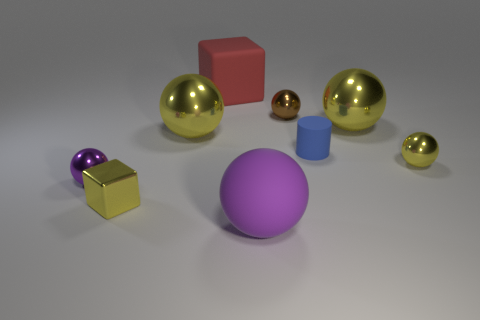There is a matte sphere; is it the same color as the tiny metallic thing that is on the left side of the tiny metal cube?
Offer a terse response. Yes. There is a object that is the same color as the big rubber ball; what shape is it?
Your response must be concise. Sphere. There is a brown metal ball; what number of small yellow shiny things are on the right side of it?
Offer a very short reply. 1. There is a large metallic ball on the left side of the tiny brown ball; is it the same color as the metallic block?
Offer a terse response. Yes. How many gray blocks have the same size as the brown thing?
Your answer should be compact. 0. What is the shape of the tiny blue object that is the same material as the large purple thing?
Provide a short and direct response. Cylinder. Are there any other matte blocks of the same color as the rubber block?
Give a very brief answer. No. What is the material of the cylinder?
Provide a short and direct response. Rubber. What number of objects are either small yellow metal things or tiny purple spheres?
Your answer should be compact. 3. There is a block in front of the tiny brown object; what is its size?
Ensure brevity in your answer.  Small. 